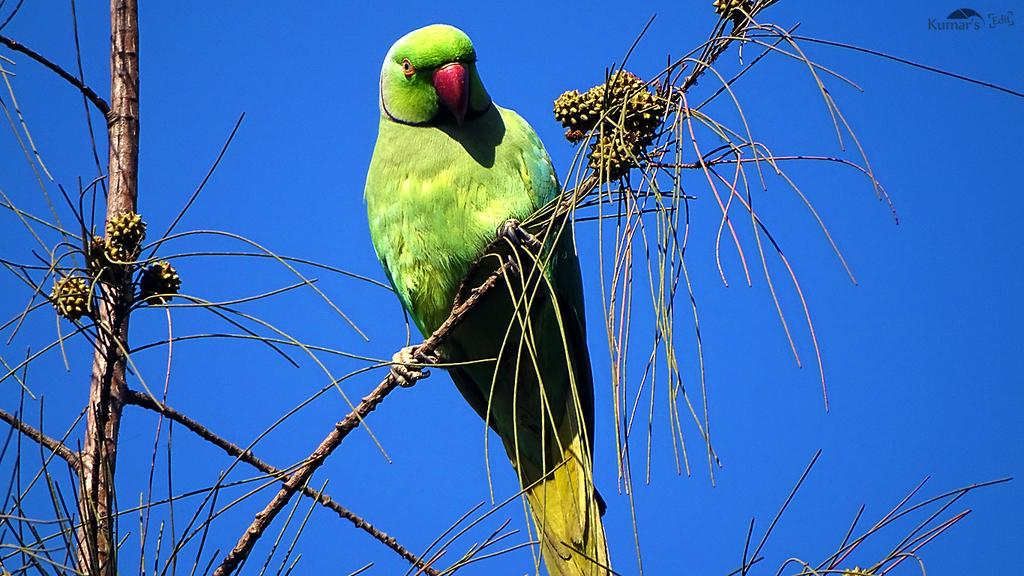What type of animal is in the image? There is a parrot in the image. Where is the parrot located? The parrot is on a tree. What can be seen on the tree besides the parrot? There are buds in the image. What is visible in the background of the image? The sky is visible in the background of the image. What type of hearing aid is the parrot wearing in the image? There is no hearing aid visible on the parrot in the image. How many hands can be seen holding the tree in the image? There are no hands visible in the image; the parrot is on the tree. 